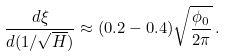Convert formula to latex. <formula><loc_0><loc_0><loc_500><loc_500>\frac { d \xi } { d ( 1 / \sqrt { H } ) } \approx ( 0 . 2 - 0 . 4 ) \sqrt { \frac { \phi _ { 0 } } { 2 \pi } } \, .</formula> 